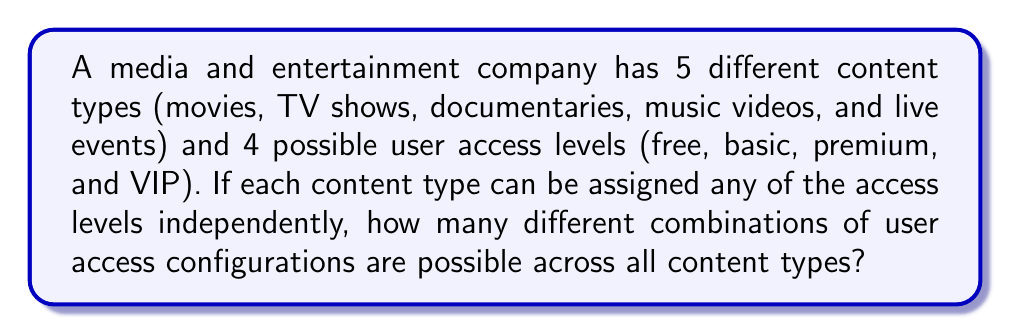Can you solve this math problem? Let's approach this step-by-step:

1) For each content type, we have 4 choices of access levels.

2) We need to make this choice independently for each of the 5 content types.

3) This scenario is a perfect example of the multiplication principle in combinatorics. When we have a series of independent choices, we multiply the number of options for each choice.

4) In this case, we have 5 independent choices (one for each content type), and each choice has 4 options (the access levels).

5) Therefore, the total number of combinations is:

   $$ 4 \times 4 \times 4 \times 4 \times 4 = 4^5 $$

6) We can calculate this:
   
   $$ 4^5 = 4 \times 4 \times 4 \times 4 \times 4 = 1024 $$

This means there are 1024 different ways to configure user access levels across all content types.
Answer: $1024$ combinations 